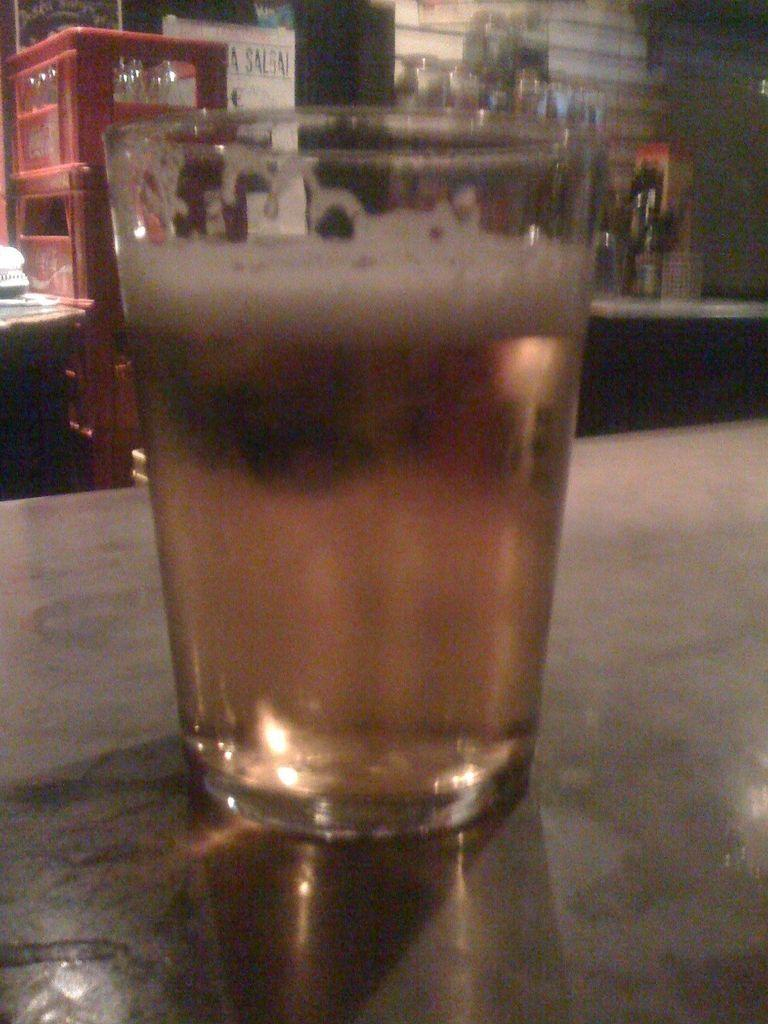What is inside the glass that is visible in the image? There is a glass containing liquid in the image. Where is the glass placed in the image? The glass is placed on a surface in the image. What can be seen on the backside of the image? There are bottles in containers on the backside of the image. What type of furniture is present in the image? There is a table in the image. What type of polish is being applied to the table in the image? There is no indication in the image that any polish is being applied to the table. 